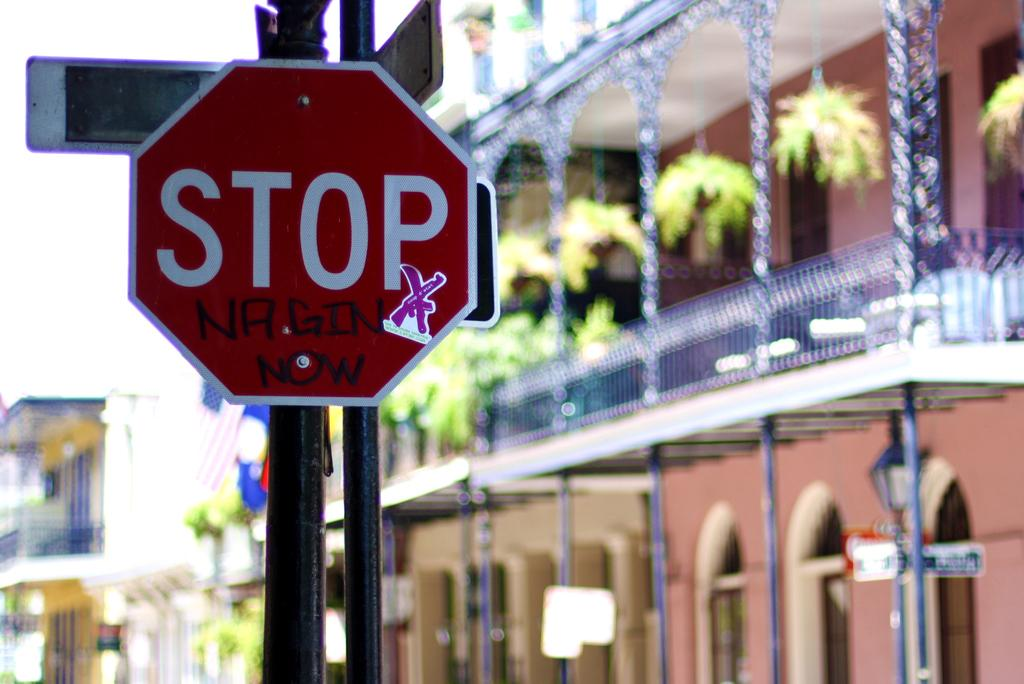<image>
Render a clear and concise summary of the photo. the word stop is on the red and white sign 